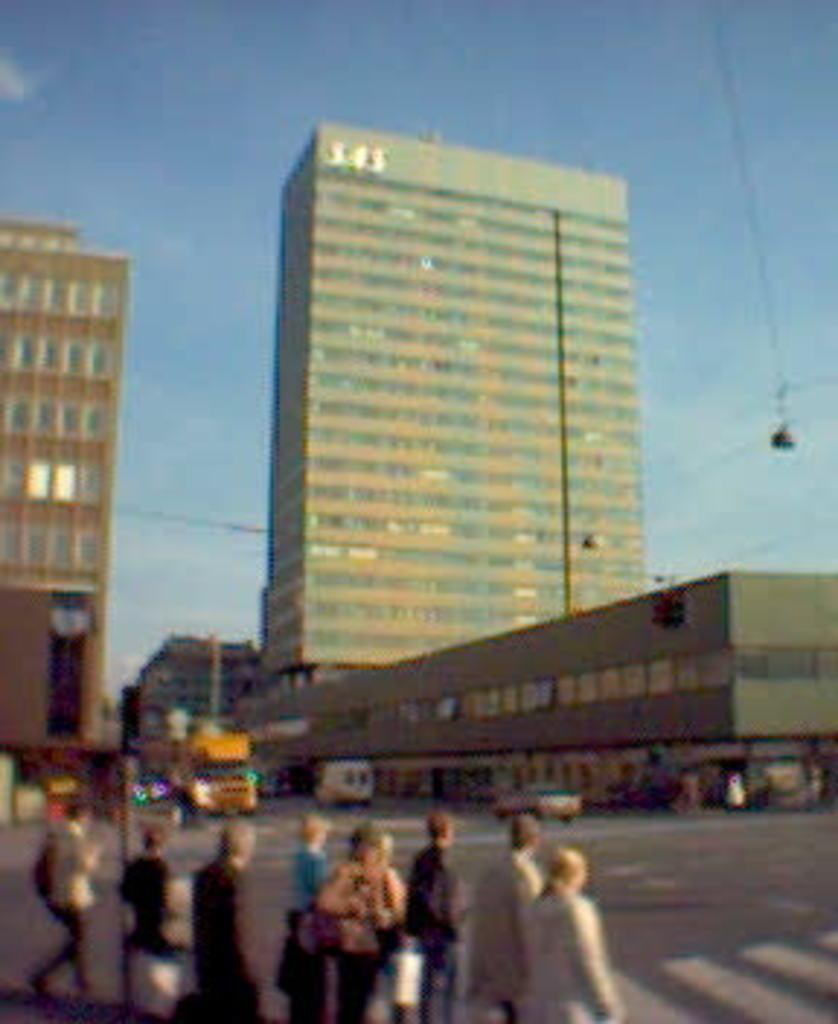Can you describe this image briefly? In this picture there is a group of men and women, crossing the road. Behind there is a big building and a yellow color bus moving on the road. 